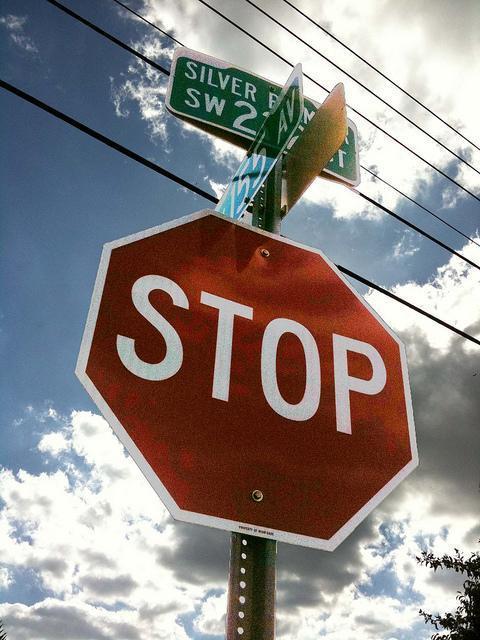How many signs are on post?
Give a very brief answer. 4. 